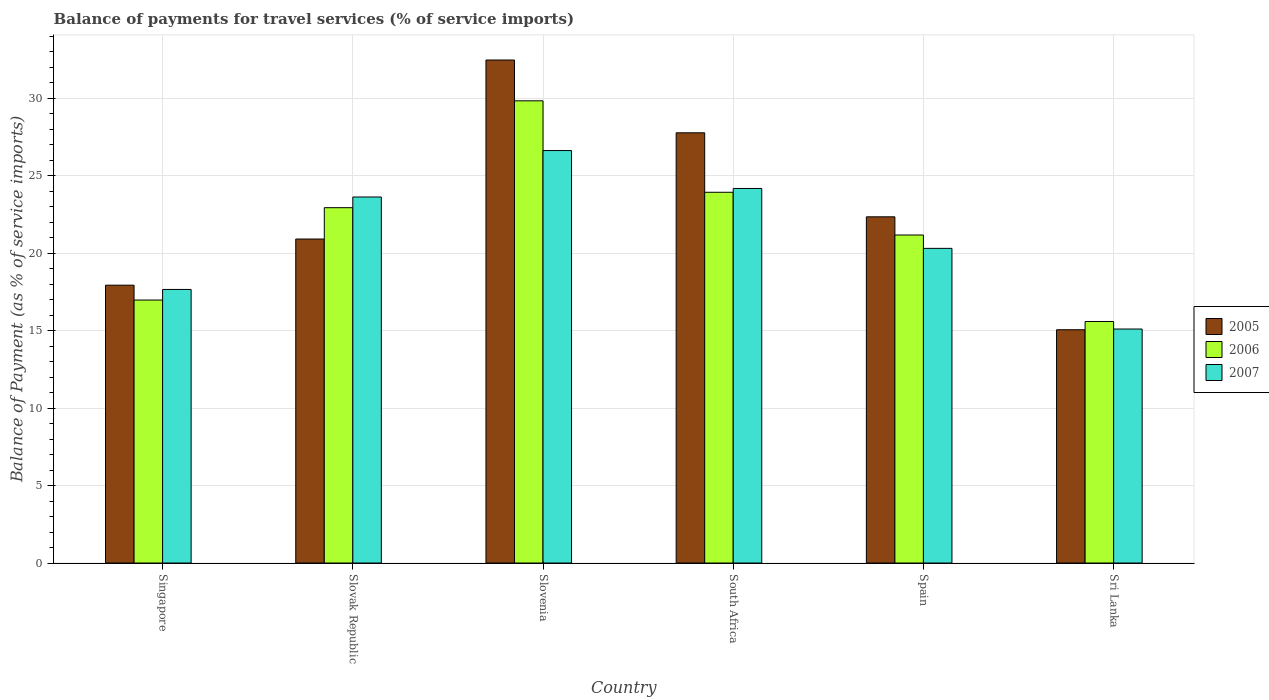How many different coloured bars are there?
Your answer should be compact. 3. How many groups of bars are there?
Provide a succinct answer. 6. Are the number of bars on each tick of the X-axis equal?
Offer a very short reply. Yes. How many bars are there on the 1st tick from the left?
Your response must be concise. 3. What is the label of the 2nd group of bars from the left?
Offer a very short reply. Slovak Republic. In how many cases, is the number of bars for a given country not equal to the number of legend labels?
Offer a very short reply. 0. What is the balance of payments for travel services in 2006 in Slovenia?
Provide a short and direct response. 29.83. Across all countries, what is the maximum balance of payments for travel services in 2005?
Give a very brief answer. 32.46. Across all countries, what is the minimum balance of payments for travel services in 2007?
Ensure brevity in your answer.  15.1. In which country was the balance of payments for travel services in 2007 maximum?
Provide a succinct answer. Slovenia. In which country was the balance of payments for travel services in 2007 minimum?
Your answer should be compact. Sri Lanka. What is the total balance of payments for travel services in 2007 in the graph?
Offer a very short reply. 127.48. What is the difference between the balance of payments for travel services in 2006 in Slovak Republic and that in Spain?
Provide a succinct answer. 1.76. What is the difference between the balance of payments for travel services in 2007 in Slovak Republic and the balance of payments for travel services in 2005 in South Africa?
Ensure brevity in your answer.  -4.14. What is the average balance of payments for travel services in 2006 per country?
Ensure brevity in your answer.  21.74. What is the difference between the balance of payments for travel services of/in 2005 and balance of payments for travel services of/in 2007 in Singapore?
Ensure brevity in your answer.  0.27. What is the ratio of the balance of payments for travel services in 2006 in Singapore to that in Spain?
Your answer should be compact. 0.8. What is the difference between the highest and the second highest balance of payments for travel services in 2005?
Give a very brief answer. 4.7. What is the difference between the highest and the lowest balance of payments for travel services in 2007?
Offer a terse response. 11.52. In how many countries, is the balance of payments for travel services in 2007 greater than the average balance of payments for travel services in 2007 taken over all countries?
Your answer should be compact. 3. Is the sum of the balance of payments for travel services in 2007 in Slovak Republic and Spain greater than the maximum balance of payments for travel services in 2006 across all countries?
Provide a short and direct response. Yes. What does the 3rd bar from the left in Slovak Republic represents?
Give a very brief answer. 2007. What does the 1st bar from the right in Slovak Republic represents?
Your response must be concise. 2007. Is it the case that in every country, the sum of the balance of payments for travel services in 2005 and balance of payments for travel services in 2006 is greater than the balance of payments for travel services in 2007?
Provide a short and direct response. Yes. Are all the bars in the graph horizontal?
Your response must be concise. No. What is the difference between two consecutive major ticks on the Y-axis?
Ensure brevity in your answer.  5. Are the values on the major ticks of Y-axis written in scientific E-notation?
Offer a very short reply. No. How are the legend labels stacked?
Provide a succinct answer. Vertical. What is the title of the graph?
Offer a terse response. Balance of payments for travel services (% of service imports). What is the label or title of the X-axis?
Offer a very short reply. Country. What is the label or title of the Y-axis?
Provide a short and direct response. Balance of Payment (as % of service imports). What is the Balance of Payment (as % of service imports) of 2005 in Singapore?
Keep it short and to the point. 17.93. What is the Balance of Payment (as % of service imports) of 2006 in Singapore?
Give a very brief answer. 16.97. What is the Balance of Payment (as % of service imports) of 2007 in Singapore?
Offer a terse response. 17.66. What is the Balance of Payment (as % of service imports) of 2005 in Slovak Republic?
Provide a succinct answer. 20.91. What is the Balance of Payment (as % of service imports) in 2006 in Slovak Republic?
Provide a succinct answer. 22.93. What is the Balance of Payment (as % of service imports) in 2007 in Slovak Republic?
Offer a terse response. 23.62. What is the Balance of Payment (as % of service imports) in 2005 in Slovenia?
Offer a terse response. 32.46. What is the Balance of Payment (as % of service imports) in 2006 in Slovenia?
Provide a succinct answer. 29.83. What is the Balance of Payment (as % of service imports) in 2007 in Slovenia?
Provide a succinct answer. 26.62. What is the Balance of Payment (as % of service imports) in 2005 in South Africa?
Give a very brief answer. 27.76. What is the Balance of Payment (as % of service imports) of 2006 in South Africa?
Your answer should be compact. 23.93. What is the Balance of Payment (as % of service imports) of 2007 in South Africa?
Provide a succinct answer. 24.17. What is the Balance of Payment (as % of service imports) in 2005 in Spain?
Ensure brevity in your answer.  22.34. What is the Balance of Payment (as % of service imports) of 2006 in Spain?
Give a very brief answer. 21.17. What is the Balance of Payment (as % of service imports) of 2007 in Spain?
Your answer should be compact. 20.31. What is the Balance of Payment (as % of service imports) of 2005 in Sri Lanka?
Keep it short and to the point. 15.06. What is the Balance of Payment (as % of service imports) of 2006 in Sri Lanka?
Your answer should be very brief. 15.59. What is the Balance of Payment (as % of service imports) of 2007 in Sri Lanka?
Provide a short and direct response. 15.1. Across all countries, what is the maximum Balance of Payment (as % of service imports) of 2005?
Make the answer very short. 32.46. Across all countries, what is the maximum Balance of Payment (as % of service imports) of 2006?
Provide a short and direct response. 29.83. Across all countries, what is the maximum Balance of Payment (as % of service imports) in 2007?
Your response must be concise. 26.62. Across all countries, what is the minimum Balance of Payment (as % of service imports) in 2005?
Your response must be concise. 15.06. Across all countries, what is the minimum Balance of Payment (as % of service imports) of 2006?
Offer a terse response. 15.59. Across all countries, what is the minimum Balance of Payment (as % of service imports) of 2007?
Ensure brevity in your answer.  15.1. What is the total Balance of Payment (as % of service imports) of 2005 in the graph?
Give a very brief answer. 136.46. What is the total Balance of Payment (as % of service imports) in 2006 in the graph?
Give a very brief answer. 130.41. What is the total Balance of Payment (as % of service imports) in 2007 in the graph?
Provide a short and direct response. 127.48. What is the difference between the Balance of Payment (as % of service imports) in 2005 in Singapore and that in Slovak Republic?
Offer a very short reply. -2.98. What is the difference between the Balance of Payment (as % of service imports) in 2006 in Singapore and that in Slovak Republic?
Your answer should be compact. -5.96. What is the difference between the Balance of Payment (as % of service imports) of 2007 in Singapore and that in Slovak Republic?
Keep it short and to the point. -5.97. What is the difference between the Balance of Payment (as % of service imports) in 2005 in Singapore and that in Slovenia?
Provide a short and direct response. -14.53. What is the difference between the Balance of Payment (as % of service imports) of 2006 in Singapore and that in Slovenia?
Your answer should be compact. -12.86. What is the difference between the Balance of Payment (as % of service imports) in 2007 in Singapore and that in Slovenia?
Give a very brief answer. -8.96. What is the difference between the Balance of Payment (as % of service imports) in 2005 in Singapore and that in South Africa?
Offer a very short reply. -9.83. What is the difference between the Balance of Payment (as % of service imports) in 2006 in Singapore and that in South Africa?
Provide a short and direct response. -6.95. What is the difference between the Balance of Payment (as % of service imports) in 2007 in Singapore and that in South Africa?
Your answer should be very brief. -6.52. What is the difference between the Balance of Payment (as % of service imports) in 2005 in Singapore and that in Spain?
Your answer should be compact. -4.41. What is the difference between the Balance of Payment (as % of service imports) in 2006 in Singapore and that in Spain?
Provide a succinct answer. -4.2. What is the difference between the Balance of Payment (as % of service imports) in 2007 in Singapore and that in Spain?
Offer a very short reply. -2.65. What is the difference between the Balance of Payment (as % of service imports) of 2005 in Singapore and that in Sri Lanka?
Offer a very short reply. 2.87. What is the difference between the Balance of Payment (as % of service imports) of 2006 in Singapore and that in Sri Lanka?
Your answer should be very brief. 1.38. What is the difference between the Balance of Payment (as % of service imports) of 2007 in Singapore and that in Sri Lanka?
Your answer should be compact. 2.55. What is the difference between the Balance of Payment (as % of service imports) of 2005 in Slovak Republic and that in Slovenia?
Your response must be concise. -11.55. What is the difference between the Balance of Payment (as % of service imports) in 2006 in Slovak Republic and that in Slovenia?
Provide a succinct answer. -6.9. What is the difference between the Balance of Payment (as % of service imports) of 2007 in Slovak Republic and that in Slovenia?
Keep it short and to the point. -3. What is the difference between the Balance of Payment (as % of service imports) of 2005 in Slovak Republic and that in South Africa?
Your answer should be compact. -6.85. What is the difference between the Balance of Payment (as % of service imports) in 2006 in Slovak Republic and that in South Africa?
Your response must be concise. -0.99. What is the difference between the Balance of Payment (as % of service imports) in 2007 in Slovak Republic and that in South Africa?
Your response must be concise. -0.55. What is the difference between the Balance of Payment (as % of service imports) of 2005 in Slovak Republic and that in Spain?
Your answer should be very brief. -1.43. What is the difference between the Balance of Payment (as % of service imports) of 2006 in Slovak Republic and that in Spain?
Provide a succinct answer. 1.76. What is the difference between the Balance of Payment (as % of service imports) in 2007 in Slovak Republic and that in Spain?
Provide a succinct answer. 3.32. What is the difference between the Balance of Payment (as % of service imports) in 2005 in Slovak Republic and that in Sri Lanka?
Provide a succinct answer. 5.85. What is the difference between the Balance of Payment (as % of service imports) of 2006 in Slovak Republic and that in Sri Lanka?
Your response must be concise. 7.35. What is the difference between the Balance of Payment (as % of service imports) in 2007 in Slovak Republic and that in Sri Lanka?
Provide a short and direct response. 8.52. What is the difference between the Balance of Payment (as % of service imports) of 2005 in Slovenia and that in South Africa?
Keep it short and to the point. 4.7. What is the difference between the Balance of Payment (as % of service imports) of 2006 in Slovenia and that in South Africa?
Your answer should be compact. 5.9. What is the difference between the Balance of Payment (as % of service imports) of 2007 in Slovenia and that in South Africa?
Keep it short and to the point. 2.45. What is the difference between the Balance of Payment (as % of service imports) in 2005 in Slovenia and that in Spain?
Ensure brevity in your answer.  10.12. What is the difference between the Balance of Payment (as % of service imports) of 2006 in Slovenia and that in Spain?
Offer a very short reply. 8.66. What is the difference between the Balance of Payment (as % of service imports) of 2007 in Slovenia and that in Spain?
Ensure brevity in your answer.  6.31. What is the difference between the Balance of Payment (as % of service imports) in 2005 in Slovenia and that in Sri Lanka?
Offer a terse response. 17.41. What is the difference between the Balance of Payment (as % of service imports) in 2006 in Slovenia and that in Sri Lanka?
Provide a short and direct response. 14.24. What is the difference between the Balance of Payment (as % of service imports) of 2007 in Slovenia and that in Sri Lanka?
Ensure brevity in your answer.  11.52. What is the difference between the Balance of Payment (as % of service imports) in 2005 in South Africa and that in Spain?
Offer a terse response. 5.42. What is the difference between the Balance of Payment (as % of service imports) of 2006 in South Africa and that in Spain?
Ensure brevity in your answer.  2.76. What is the difference between the Balance of Payment (as % of service imports) in 2007 in South Africa and that in Spain?
Provide a short and direct response. 3.87. What is the difference between the Balance of Payment (as % of service imports) of 2005 in South Africa and that in Sri Lanka?
Offer a very short reply. 12.71. What is the difference between the Balance of Payment (as % of service imports) of 2006 in South Africa and that in Sri Lanka?
Give a very brief answer. 8.34. What is the difference between the Balance of Payment (as % of service imports) in 2007 in South Africa and that in Sri Lanka?
Provide a succinct answer. 9.07. What is the difference between the Balance of Payment (as % of service imports) in 2005 in Spain and that in Sri Lanka?
Provide a short and direct response. 7.29. What is the difference between the Balance of Payment (as % of service imports) of 2006 in Spain and that in Sri Lanka?
Offer a very short reply. 5.58. What is the difference between the Balance of Payment (as % of service imports) of 2007 in Spain and that in Sri Lanka?
Make the answer very short. 5.21. What is the difference between the Balance of Payment (as % of service imports) in 2005 in Singapore and the Balance of Payment (as % of service imports) in 2006 in Slovak Republic?
Ensure brevity in your answer.  -5. What is the difference between the Balance of Payment (as % of service imports) in 2005 in Singapore and the Balance of Payment (as % of service imports) in 2007 in Slovak Republic?
Offer a terse response. -5.69. What is the difference between the Balance of Payment (as % of service imports) in 2006 in Singapore and the Balance of Payment (as % of service imports) in 2007 in Slovak Republic?
Offer a terse response. -6.65. What is the difference between the Balance of Payment (as % of service imports) in 2005 in Singapore and the Balance of Payment (as % of service imports) in 2006 in Slovenia?
Provide a succinct answer. -11.9. What is the difference between the Balance of Payment (as % of service imports) of 2005 in Singapore and the Balance of Payment (as % of service imports) of 2007 in Slovenia?
Make the answer very short. -8.69. What is the difference between the Balance of Payment (as % of service imports) in 2006 in Singapore and the Balance of Payment (as % of service imports) in 2007 in Slovenia?
Ensure brevity in your answer.  -9.65. What is the difference between the Balance of Payment (as % of service imports) of 2005 in Singapore and the Balance of Payment (as % of service imports) of 2006 in South Africa?
Keep it short and to the point. -6. What is the difference between the Balance of Payment (as % of service imports) of 2005 in Singapore and the Balance of Payment (as % of service imports) of 2007 in South Africa?
Your answer should be compact. -6.24. What is the difference between the Balance of Payment (as % of service imports) in 2006 in Singapore and the Balance of Payment (as % of service imports) in 2007 in South Africa?
Your answer should be compact. -7.2. What is the difference between the Balance of Payment (as % of service imports) in 2005 in Singapore and the Balance of Payment (as % of service imports) in 2006 in Spain?
Offer a terse response. -3.24. What is the difference between the Balance of Payment (as % of service imports) in 2005 in Singapore and the Balance of Payment (as % of service imports) in 2007 in Spain?
Your answer should be compact. -2.38. What is the difference between the Balance of Payment (as % of service imports) of 2006 in Singapore and the Balance of Payment (as % of service imports) of 2007 in Spain?
Offer a very short reply. -3.33. What is the difference between the Balance of Payment (as % of service imports) in 2005 in Singapore and the Balance of Payment (as % of service imports) in 2006 in Sri Lanka?
Provide a short and direct response. 2.34. What is the difference between the Balance of Payment (as % of service imports) of 2005 in Singapore and the Balance of Payment (as % of service imports) of 2007 in Sri Lanka?
Provide a short and direct response. 2.83. What is the difference between the Balance of Payment (as % of service imports) of 2006 in Singapore and the Balance of Payment (as % of service imports) of 2007 in Sri Lanka?
Your answer should be very brief. 1.87. What is the difference between the Balance of Payment (as % of service imports) of 2005 in Slovak Republic and the Balance of Payment (as % of service imports) of 2006 in Slovenia?
Offer a terse response. -8.92. What is the difference between the Balance of Payment (as % of service imports) of 2005 in Slovak Republic and the Balance of Payment (as % of service imports) of 2007 in Slovenia?
Provide a succinct answer. -5.71. What is the difference between the Balance of Payment (as % of service imports) of 2006 in Slovak Republic and the Balance of Payment (as % of service imports) of 2007 in Slovenia?
Keep it short and to the point. -3.69. What is the difference between the Balance of Payment (as % of service imports) in 2005 in Slovak Republic and the Balance of Payment (as % of service imports) in 2006 in South Africa?
Provide a succinct answer. -3.02. What is the difference between the Balance of Payment (as % of service imports) in 2005 in Slovak Republic and the Balance of Payment (as % of service imports) in 2007 in South Africa?
Provide a succinct answer. -3.26. What is the difference between the Balance of Payment (as % of service imports) in 2006 in Slovak Republic and the Balance of Payment (as % of service imports) in 2007 in South Africa?
Provide a short and direct response. -1.24. What is the difference between the Balance of Payment (as % of service imports) in 2005 in Slovak Republic and the Balance of Payment (as % of service imports) in 2006 in Spain?
Offer a terse response. -0.26. What is the difference between the Balance of Payment (as % of service imports) of 2005 in Slovak Republic and the Balance of Payment (as % of service imports) of 2007 in Spain?
Provide a short and direct response. 0.6. What is the difference between the Balance of Payment (as % of service imports) in 2006 in Slovak Republic and the Balance of Payment (as % of service imports) in 2007 in Spain?
Keep it short and to the point. 2.63. What is the difference between the Balance of Payment (as % of service imports) in 2005 in Slovak Republic and the Balance of Payment (as % of service imports) in 2006 in Sri Lanka?
Your answer should be compact. 5.32. What is the difference between the Balance of Payment (as % of service imports) in 2005 in Slovak Republic and the Balance of Payment (as % of service imports) in 2007 in Sri Lanka?
Your answer should be very brief. 5.81. What is the difference between the Balance of Payment (as % of service imports) in 2006 in Slovak Republic and the Balance of Payment (as % of service imports) in 2007 in Sri Lanka?
Offer a terse response. 7.83. What is the difference between the Balance of Payment (as % of service imports) in 2005 in Slovenia and the Balance of Payment (as % of service imports) in 2006 in South Africa?
Your answer should be compact. 8.53. What is the difference between the Balance of Payment (as % of service imports) in 2005 in Slovenia and the Balance of Payment (as % of service imports) in 2007 in South Africa?
Make the answer very short. 8.29. What is the difference between the Balance of Payment (as % of service imports) of 2006 in Slovenia and the Balance of Payment (as % of service imports) of 2007 in South Africa?
Your response must be concise. 5.66. What is the difference between the Balance of Payment (as % of service imports) in 2005 in Slovenia and the Balance of Payment (as % of service imports) in 2006 in Spain?
Provide a succinct answer. 11.29. What is the difference between the Balance of Payment (as % of service imports) in 2005 in Slovenia and the Balance of Payment (as % of service imports) in 2007 in Spain?
Your answer should be very brief. 12.15. What is the difference between the Balance of Payment (as % of service imports) of 2006 in Slovenia and the Balance of Payment (as % of service imports) of 2007 in Spain?
Make the answer very short. 9.52. What is the difference between the Balance of Payment (as % of service imports) of 2005 in Slovenia and the Balance of Payment (as % of service imports) of 2006 in Sri Lanka?
Your answer should be compact. 16.87. What is the difference between the Balance of Payment (as % of service imports) in 2005 in Slovenia and the Balance of Payment (as % of service imports) in 2007 in Sri Lanka?
Ensure brevity in your answer.  17.36. What is the difference between the Balance of Payment (as % of service imports) of 2006 in Slovenia and the Balance of Payment (as % of service imports) of 2007 in Sri Lanka?
Offer a very short reply. 14.73. What is the difference between the Balance of Payment (as % of service imports) of 2005 in South Africa and the Balance of Payment (as % of service imports) of 2006 in Spain?
Your response must be concise. 6.59. What is the difference between the Balance of Payment (as % of service imports) in 2005 in South Africa and the Balance of Payment (as % of service imports) in 2007 in Spain?
Provide a short and direct response. 7.46. What is the difference between the Balance of Payment (as % of service imports) in 2006 in South Africa and the Balance of Payment (as % of service imports) in 2007 in Spain?
Provide a short and direct response. 3.62. What is the difference between the Balance of Payment (as % of service imports) of 2005 in South Africa and the Balance of Payment (as % of service imports) of 2006 in Sri Lanka?
Offer a terse response. 12.18. What is the difference between the Balance of Payment (as % of service imports) in 2005 in South Africa and the Balance of Payment (as % of service imports) in 2007 in Sri Lanka?
Give a very brief answer. 12.66. What is the difference between the Balance of Payment (as % of service imports) in 2006 in South Africa and the Balance of Payment (as % of service imports) in 2007 in Sri Lanka?
Ensure brevity in your answer.  8.82. What is the difference between the Balance of Payment (as % of service imports) of 2005 in Spain and the Balance of Payment (as % of service imports) of 2006 in Sri Lanka?
Your answer should be very brief. 6.75. What is the difference between the Balance of Payment (as % of service imports) of 2005 in Spain and the Balance of Payment (as % of service imports) of 2007 in Sri Lanka?
Your response must be concise. 7.24. What is the difference between the Balance of Payment (as % of service imports) of 2006 in Spain and the Balance of Payment (as % of service imports) of 2007 in Sri Lanka?
Provide a short and direct response. 6.07. What is the average Balance of Payment (as % of service imports) of 2005 per country?
Provide a short and direct response. 22.74. What is the average Balance of Payment (as % of service imports) in 2006 per country?
Your response must be concise. 21.74. What is the average Balance of Payment (as % of service imports) in 2007 per country?
Give a very brief answer. 21.25. What is the difference between the Balance of Payment (as % of service imports) of 2005 and Balance of Payment (as % of service imports) of 2006 in Singapore?
Your answer should be very brief. 0.96. What is the difference between the Balance of Payment (as % of service imports) in 2005 and Balance of Payment (as % of service imports) in 2007 in Singapore?
Provide a succinct answer. 0.27. What is the difference between the Balance of Payment (as % of service imports) in 2006 and Balance of Payment (as % of service imports) in 2007 in Singapore?
Offer a very short reply. -0.68. What is the difference between the Balance of Payment (as % of service imports) in 2005 and Balance of Payment (as % of service imports) in 2006 in Slovak Republic?
Provide a succinct answer. -2.02. What is the difference between the Balance of Payment (as % of service imports) in 2005 and Balance of Payment (as % of service imports) in 2007 in Slovak Republic?
Your answer should be very brief. -2.71. What is the difference between the Balance of Payment (as % of service imports) of 2006 and Balance of Payment (as % of service imports) of 2007 in Slovak Republic?
Provide a short and direct response. -0.69. What is the difference between the Balance of Payment (as % of service imports) of 2005 and Balance of Payment (as % of service imports) of 2006 in Slovenia?
Provide a succinct answer. 2.63. What is the difference between the Balance of Payment (as % of service imports) of 2005 and Balance of Payment (as % of service imports) of 2007 in Slovenia?
Make the answer very short. 5.84. What is the difference between the Balance of Payment (as % of service imports) of 2006 and Balance of Payment (as % of service imports) of 2007 in Slovenia?
Make the answer very short. 3.21. What is the difference between the Balance of Payment (as % of service imports) in 2005 and Balance of Payment (as % of service imports) in 2006 in South Africa?
Make the answer very short. 3.84. What is the difference between the Balance of Payment (as % of service imports) in 2005 and Balance of Payment (as % of service imports) in 2007 in South Africa?
Offer a terse response. 3.59. What is the difference between the Balance of Payment (as % of service imports) of 2006 and Balance of Payment (as % of service imports) of 2007 in South Africa?
Your answer should be very brief. -0.25. What is the difference between the Balance of Payment (as % of service imports) of 2005 and Balance of Payment (as % of service imports) of 2006 in Spain?
Give a very brief answer. 1.17. What is the difference between the Balance of Payment (as % of service imports) in 2005 and Balance of Payment (as % of service imports) in 2007 in Spain?
Your answer should be compact. 2.04. What is the difference between the Balance of Payment (as % of service imports) in 2006 and Balance of Payment (as % of service imports) in 2007 in Spain?
Ensure brevity in your answer.  0.86. What is the difference between the Balance of Payment (as % of service imports) in 2005 and Balance of Payment (as % of service imports) in 2006 in Sri Lanka?
Your answer should be very brief. -0.53. What is the difference between the Balance of Payment (as % of service imports) in 2005 and Balance of Payment (as % of service imports) in 2007 in Sri Lanka?
Your answer should be compact. -0.05. What is the difference between the Balance of Payment (as % of service imports) of 2006 and Balance of Payment (as % of service imports) of 2007 in Sri Lanka?
Offer a terse response. 0.49. What is the ratio of the Balance of Payment (as % of service imports) in 2005 in Singapore to that in Slovak Republic?
Your answer should be compact. 0.86. What is the ratio of the Balance of Payment (as % of service imports) of 2006 in Singapore to that in Slovak Republic?
Keep it short and to the point. 0.74. What is the ratio of the Balance of Payment (as % of service imports) in 2007 in Singapore to that in Slovak Republic?
Ensure brevity in your answer.  0.75. What is the ratio of the Balance of Payment (as % of service imports) in 2005 in Singapore to that in Slovenia?
Your answer should be very brief. 0.55. What is the ratio of the Balance of Payment (as % of service imports) of 2006 in Singapore to that in Slovenia?
Ensure brevity in your answer.  0.57. What is the ratio of the Balance of Payment (as % of service imports) of 2007 in Singapore to that in Slovenia?
Your answer should be very brief. 0.66. What is the ratio of the Balance of Payment (as % of service imports) in 2005 in Singapore to that in South Africa?
Your response must be concise. 0.65. What is the ratio of the Balance of Payment (as % of service imports) of 2006 in Singapore to that in South Africa?
Provide a short and direct response. 0.71. What is the ratio of the Balance of Payment (as % of service imports) in 2007 in Singapore to that in South Africa?
Provide a succinct answer. 0.73. What is the ratio of the Balance of Payment (as % of service imports) of 2005 in Singapore to that in Spain?
Offer a very short reply. 0.8. What is the ratio of the Balance of Payment (as % of service imports) in 2006 in Singapore to that in Spain?
Give a very brief answer. 0.8. What is the ratio of the Balance of Payment (as % of service imports) in 2007 in Singapore to that in Spain?
Your response must be concise. 0.87. What is the ratio of the Balance of Payment (as % of service imports) of 2005 in Singapore to that in Sri Lanka?
Give a very brief answer. 1.19. What is the ratio of the Balance of Payment (as % of service imports) in 2006 in Singapore to that in Sri Lanka?
Keep it short and to the point. 1.09. What is the ratio of the Balance of Payment (as % of service imports) of 2007 in Singapore to that in Sri Lanka?
Provide a succinct answer. 1.17. What is the ratio of the Balance of Payment (as % of service imports) in 2005 in Slovak Republic to that in Slovenia?
Your answer should be very brief. 0.64. What is the ratio of the Balance of Payment (as % of service imports) in 2006 in Slovak Republic to that in Slovenia?
Your response must be concise. 0.77. What is the ratio of the Balance of Payment (as % of service imports) of 2007 in Slovak Republic to that in Slovenia?
Ensure brevity in your answer.  0.89. What is the ratio of the Balance of Payment (as % of service imports) of 2005 in Slovak Republic to that in South Africa?
Offer a very short reply. 0.75. What is the ratio of the Balance of Payment (as % of service imports) in 2006 in Slovak Republic to that in South Africa?
Your response must be concise. 0.96. What is the ratio of the Balance of Payment (as % of service imports) of 2007 in Slovak Republic to that in South Africa?
Provide a succinct answer. 0.98. What is the ratio of the Balance of Payment (as % of service imports) of 2005 in Slovak Republic to that in Spain?
Offer a terse response. 0.94. What is the ratio of the Balance of Payment (as % of service imports) in 2006 in Slovak Republic to that in Spain?
Give a very brief answer. 1.08. What is the ratio of the Balance of Payment (as % of service imports) in 2007 in Slovak Republic to that in Spain?
Offer a terse response. 1.16. What is the ratio of the Balance of Payment (as % of service imports) in 2005 in Slovak Republic to that in Sri Lanka?
Make the answer very short. 1.39. What is the ratio of the Balance of Payment (as % of service imports) in 2006 in Slovak Republic to that in Sri Lanka?
Make the answer very short. 1.47. What is the ratio of the Balance of Payment (as % of service imports) in 2007 in Slovak Republic to that in Sri Lanka?
Your answer should be compact. 1.56. What is the ratio of the Balance of Payment (as % of service imports) of 2005 in Slovenia to that in South Africa?
Keep it short and to the point. 1.17. What is the ratio of the Balance of Payment (as % of service imports) in 2006 in Slovenia to that in South Africa?
Make the answer very short. 1.25. What is the ratio of the Balance of Payment (as % of service imports) in 2007 in Slovenia to that in South Africa?
Keep it short and to the point. 1.1. What is the ratio of the Balance of Payment (as % of service imports) of 2005 in Slovenia to that in Spain?
Make the answer very short. 1.45. What is the ratio of the Balance of Payment (as % of service imports) of 2006 in Slovenia to that in Spain?
Provide a short and direct response. 1.41. What is the ratio of the Balance of Payment (as % of service imports) of 2007 in Slovenia to that in Spain?
Offer a very short reply. 1.31. What is the ratio of the Balance of Payment (as % of service imports) of 2005 in Slovenia to that in Sri Lanka?
Your answer should be compact. 2.16. What is the ratio of the Balance of Payment (as % of service imports) of 2006 in Slovenia to that in Sri Lanka?
Your answer should be compact. 1.91. What is the ratio of the Balance of Payment (as % of service imports) in 2007 in Slovenia to that in Sri Lanka?
Make the answer very short. 1.76. What is the ratio of the Balance of Payment (as % of service imports) of 2005 in South Africa to that in Spain?
Your answer should be very brief. 1.24. What is the ratio of the Balance of Payment (as % of service imports) in 2006 in South Africa to that in Spain?
Make the answer very short. 1.13. What is the ratio of the Balance of Payment (as % of service imports) of 2007 in South Africa to that in Spain?
Your response must be concise. 1.19. What is the ratio of the Balance of Payment (as % of service imports) in 2005 in South Africa to that in Sri Lanka?
Your response must be concise. 1.84. What is the ratio of the Balance of Payment (as % of service imports) in 2006 in South Africa to that in Sri Lanka?
Your answer should be compact. 1.53. What is the ratio of the Balance of Payment (as % of service imports) in 2007 in South Africa to that in Sri Lanka?
Make the answer very short. 1.6. What is the ratio of the Balance of Payment (as % of service imports) in 2005 in Spain to that in Sri Lanka?
Your answer should be very brief. 1.48. What is the ratio of the Balance of Payment (as % of service imports) in 2006 in Spain to that in Sri Lanka?
Offer a terse response. 1.36. What is the ratio of the Balance of Payment (as % of service imports) in 2007 in Spain to that in Sri Lanka?
Offer a very short reply. 1.34. What is the difference between the highest and the second highest Balance of Payment (as % of service imports) in 2005?
Your answer should be compact. 4.7. What is the difference between the highest and the second highest Balance of Payment (as % of service imports) of 2006?
Make the answer very short. 5.9. What is the difference between the highest and the second highest Balance of Payment (as % of service imports) of 2007?
Your response must be concise. 2.45. What is the difference between the highest and the lowest Balance of Payment (as % of service imports) of 2005?
Ensure brevity in your answer.  17.41. What is the difference between the highest and the lowest Balance of Payment (as % of service imports) in 2006?
Keep it short and to the point. 14.24. What is the difference between the highest and the lowest Balance of Payment (as % of service imports) in 2007?
Provide a short and direct response. 11.52. 